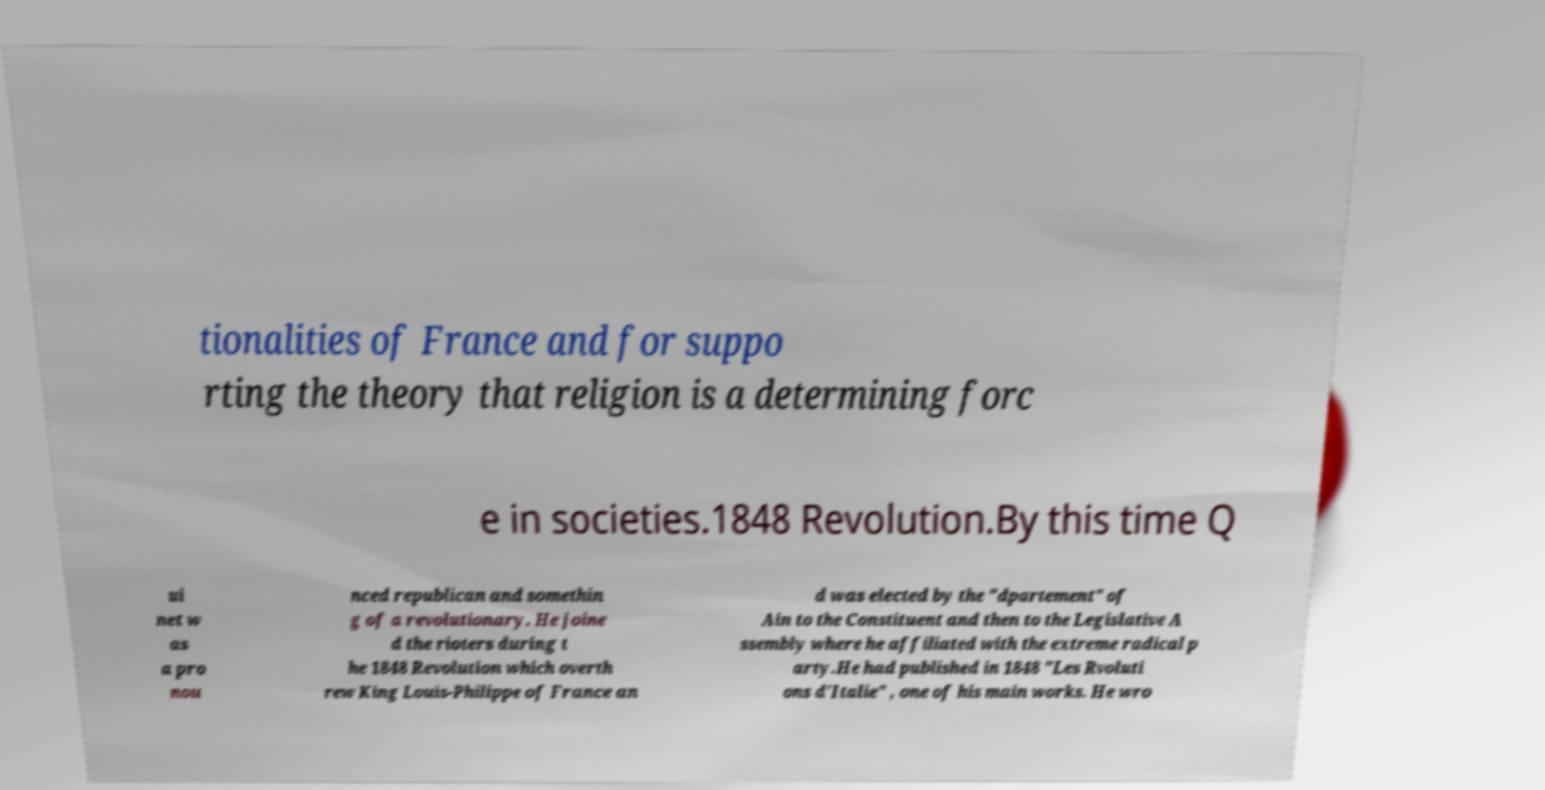Please identify and transcribe the text found in this image. tionalities of France and for suppo rting the theory that religion is a determining forc e in societies.1848 Revolution.By this time Q ui net w as a pro nou nced republican and somethin g of a revolutionary. He joine d the rioters during t he 1848 Revolution which overth rew King Louis-Philippe of France an d was elected by the "dpartement" of Ain to the Constituent and then to the Legislative A ssembly where he affiliated with the extreme radical p arty.He had published in 1848 "Les Rvoluti ons d'Italie" , one of his main works. He wro 